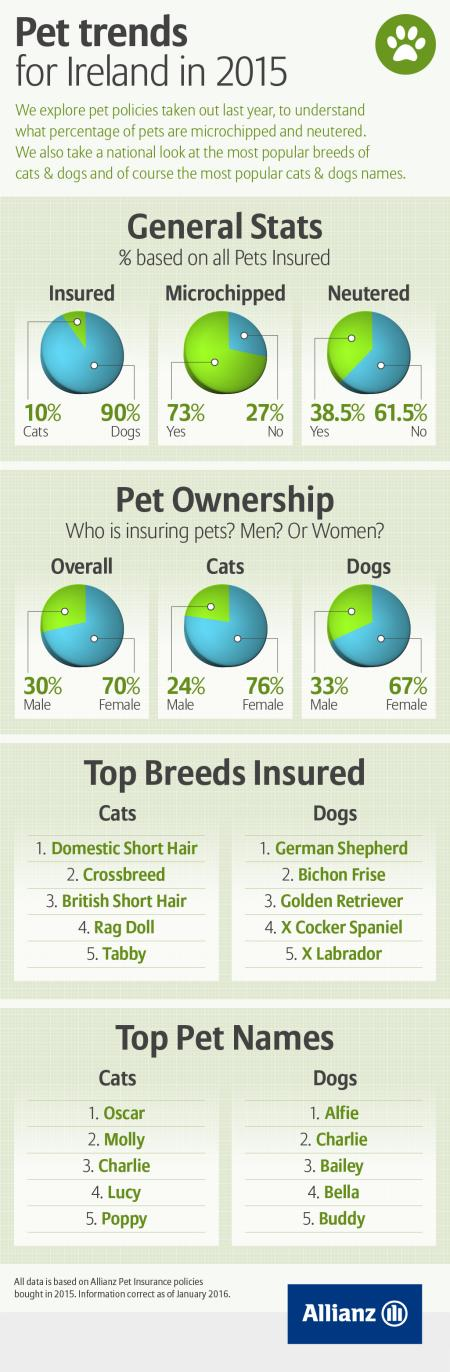Outline some significant characteristics in this image. Seventy-three percent of pets are microchipped," asserts the survey data. It is unclear who is insuring dogs the most, as the information provided is limited to gender. It is female cats that are being insured the most, as compared to male cats. In the United States, approximately 38.5% of pets are neutered, indicating a growing trend towards responsible pet ownership. 